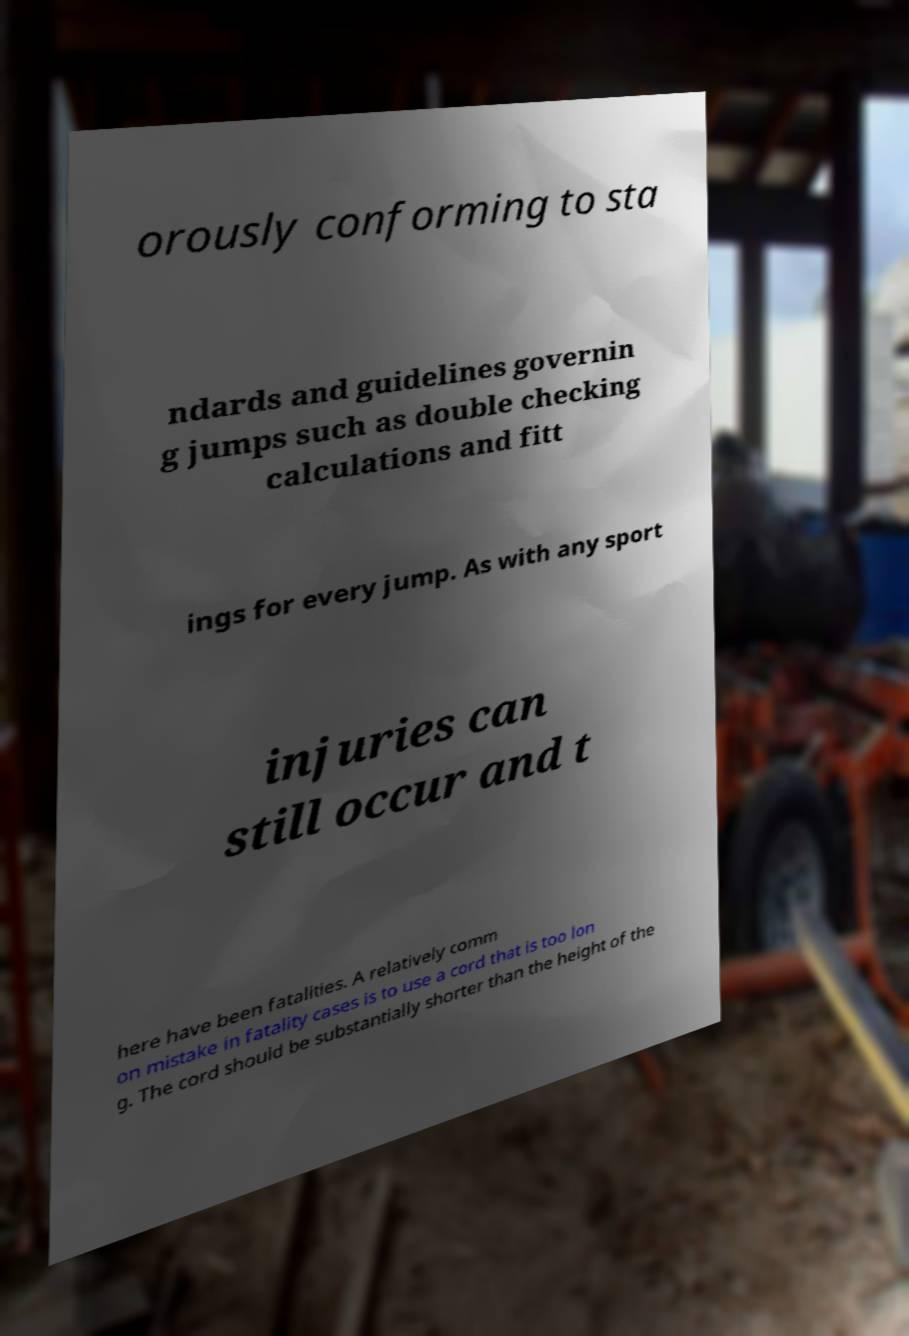Can you read and provide the text displayed in the image?This photo seems to have some interesting text. Can you extract and type it out for me? orously conforming to sta ndards and guidelines governin g jumps such as double checking calculations and fitt ings for every jump. As with any sport injuries can still occur and t here have been fatalities. A relatively comm on mistake in fatality cases is to use a cord that is too lon g. The cord should be substantially shorter than the height of the 